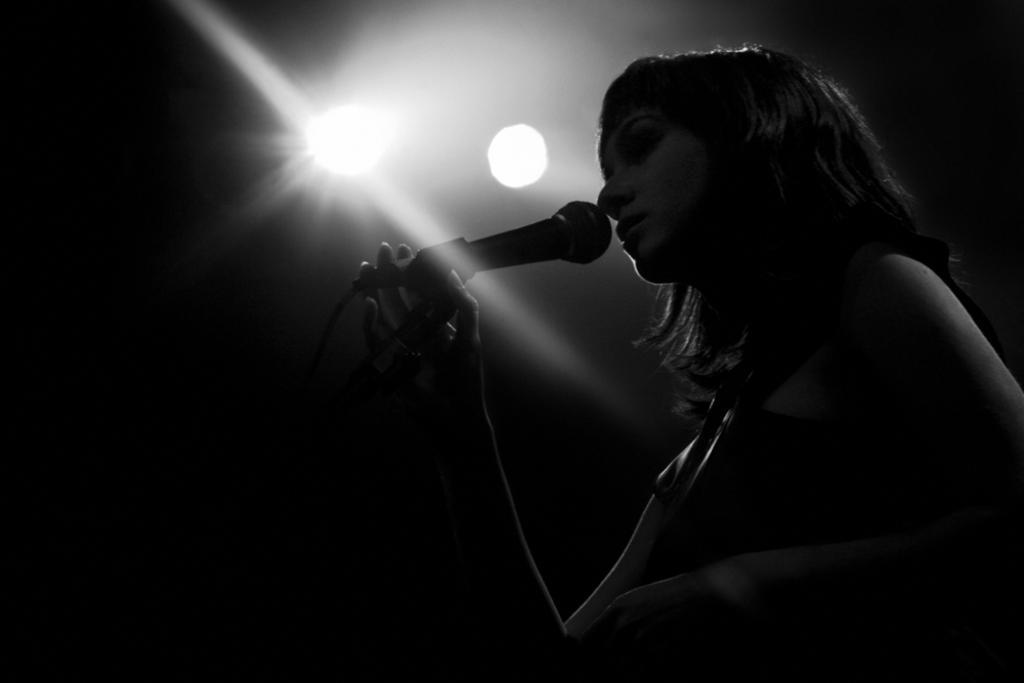Please provide a concise description of this image. This person holding microphone. On the top we can see lights. 